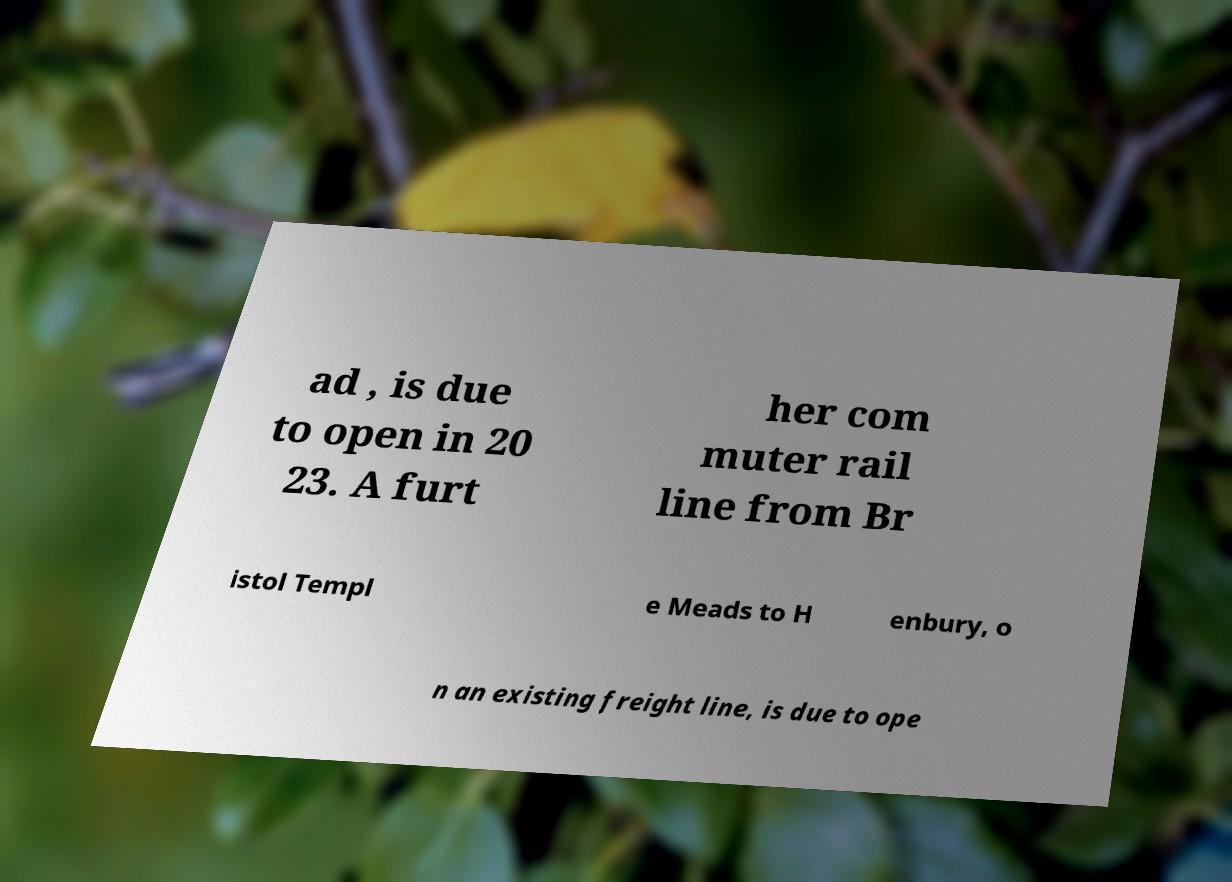What messages or text are displayed in this image? I need them in a readable, typed format. ad , is due to open in 20 23. A furt her com muter rail line from Br istol Templ e Meads to H enbury, o n an existing freight line, is due to ope 